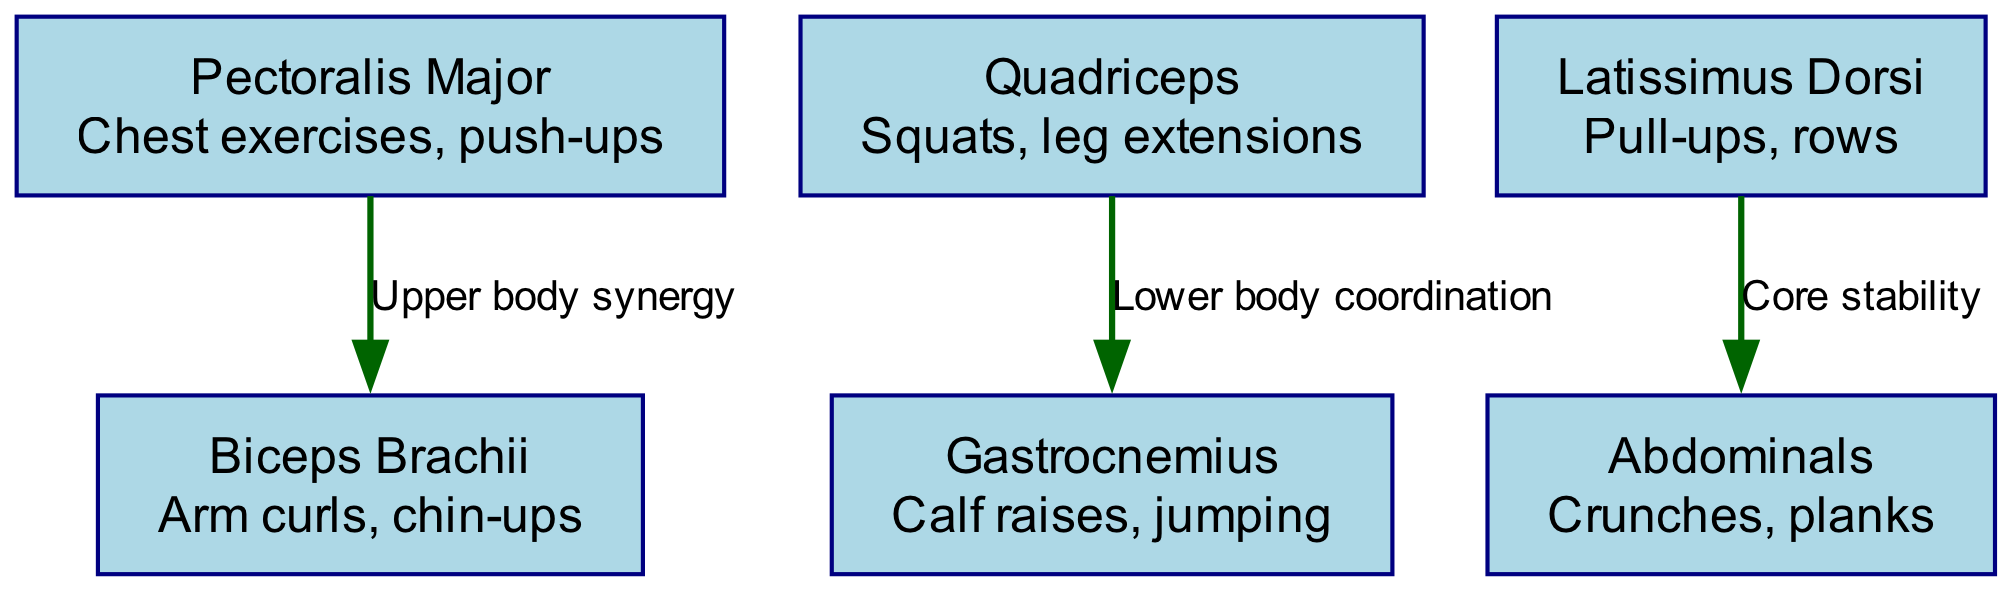What is the function of the Pectoralis Major? The diagram lists the function of the Pectoralis Major as "Chest exercises, push-ups". We can find this information in the node corresponding to the Pectoralis Major.
Answer: Chest exercises, push-ups How many major muscle groups are shown in the diagram? The diagram displays six nodes representing different muscle groups. By counting the nodes provided in the data, we see the total is six.
Answer: 6 What type of exercise involves the Biceps Brachii? According to the diagram, the function associated with the Biceps Brachii is given as "Arm curls, chin-ups". The node allows us to easily identify this exercise type.
Answer: Arm curls, chin-ups Which muscle group is associated with core stability? The diagram shows that the Latissimus Dorsi is linked to "Core stability". By referring to the edges connecting the nodes, we confirm that this is the core stability-related muscle.
Answer: Latissimus Dorsi What is the relationship labeled between Quadriceps and Gastrocnemius? The diagram indicates "Lower body coordination" as the label denoting the relationship from Quadriceps to Gastrocnemius. Tracing the edge connecting these nodes gives us the label.
Answer: Lower body coordination What two muscle groups are connected by the label "Upper body synergy"? The edges in the diagram show a connection labeled "Upper body synergy" between the Pectoralis Major and Biceps Brachii. Looking specifically at this edge indicates the connected muscle groups.
Answer: Pectoralis Major and Biceps Brachii What are the functions of the Abdominals? The function associated with the Abdominals is "Crunches, planks". This information can be directly gathered from the respective node in the diagram.
Answer: Crunches, planks How do the Latissimus Dorsi and Abdominals relate? The diagram illustrates a relationship where the Latissimus Dorsi connects to the Abdominals for "Core stability". Examining the edge between these two nodes helps us determine their relationship.
Answer: Core stability 